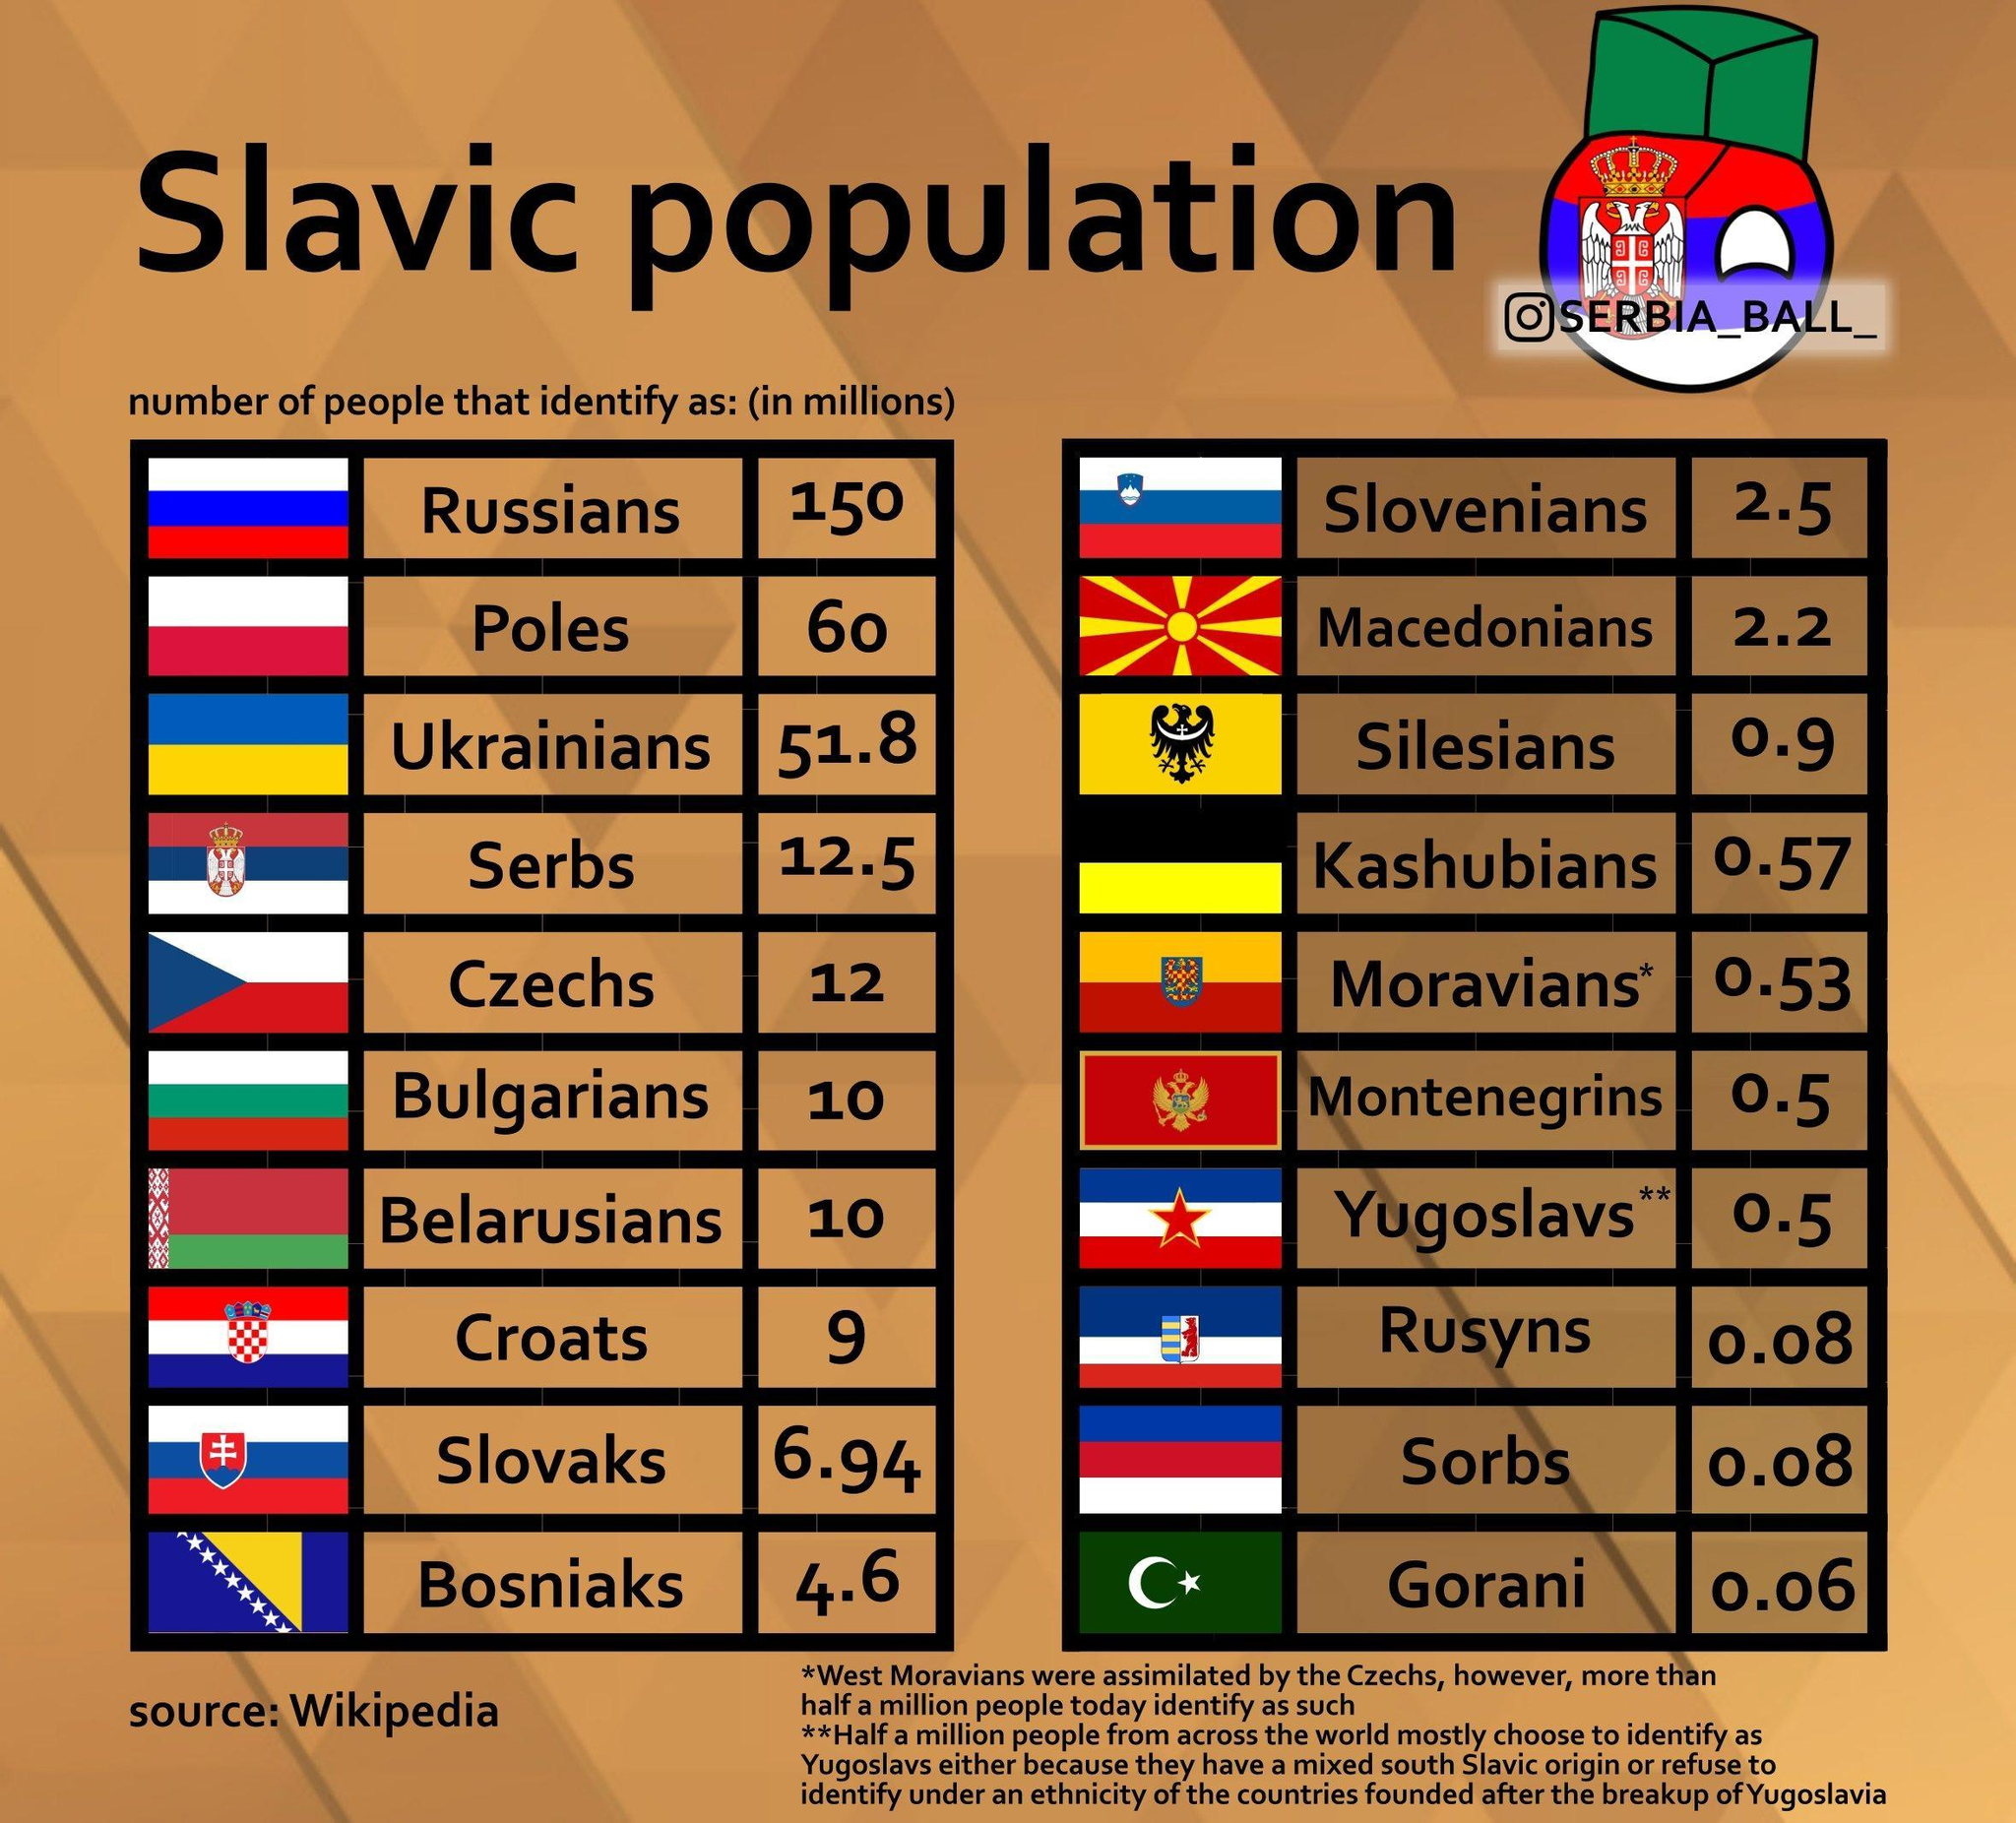What is the Slavic Population of Silesians and Rusyns, taken together?
Answer the question with a short phrase. 0.98 What is the Slavic Population of Bulgarians and Croats, taken together? 19 What is the Slavic Population of Serbs and Czechs, taken together? 24.5 What is the Slavic Population of Sorbs and Gorani, taken together? 0.14 What is the Slavic Population of Russians and Poles, taken together? 210 What is the Slavic population of Slovaks and Bosniaks, taken together? 11.54 